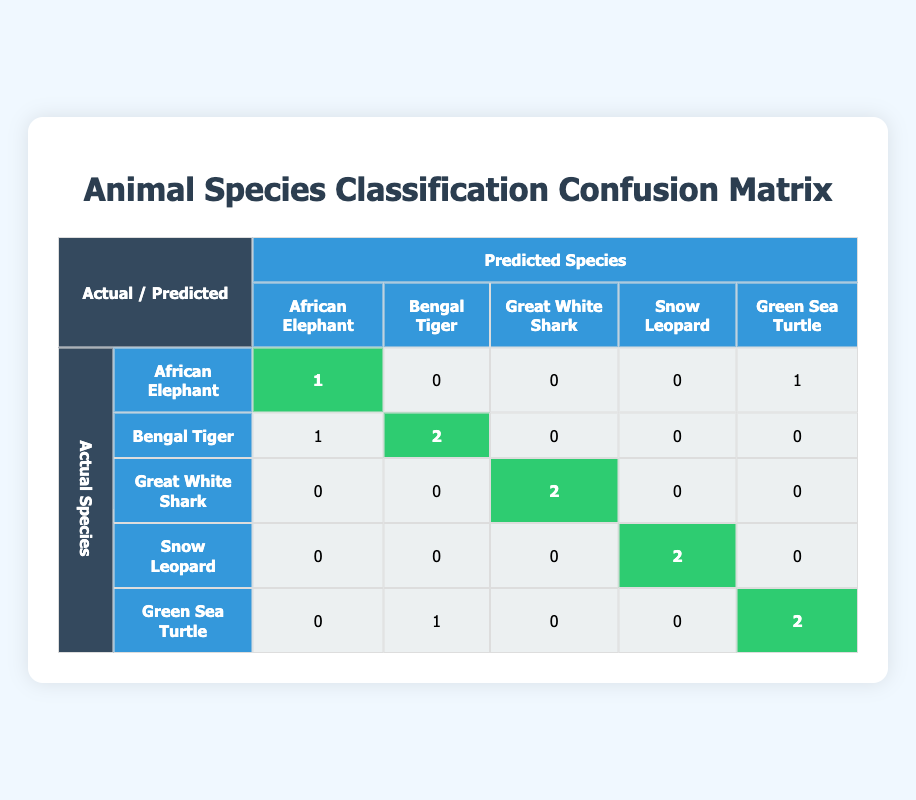What is the number of Bengal Tigers predicted correctly? In the confusion matrix, we look at the row for Bengal Tiger. The diagonal cell for Bengal Tiger shows a value of 2, which represents the number of times the model correctly predicted it as a Bengal Tiger.
Answer: 2 How many species were misclassified as African Elephants? To find the misclassifications, we look at the column for African Elephant. We see that there is a value of 1 for Bengal Tiger, indicating that one Bengal Tiger was incorrectly predicted as an African Elephant.
Answer: 1 What is the total number of misclassifications across all species? We need to sum all the off-diagonal values in the confusion matrix to get the total misclassifications. For all species, the values are 0 (African Elephant) + 1 (Bengal Tiger) + 0 (Great White Shark) + 0 (Snow Leopard) + 0 (Green Sea Turtle) = 1 for African Elephant, and so on. Summing them up gives us 1 + 1 + 0 + 0 + 1 = 3.
Answer: 3 True or False: Great White Shark was predicted correctly two times. Looking at the row for Great White Shark, we see that the diagonal cell has a value of 2, which indicates that it was predicted correctly two times. Therefore, the statement holds true.
Answer: True What is the average number of correct predictions for each species? To find the average correct predictions, we sum the diagonal values (true positives) which are 1 (African Elephant) + 2 (Bengal Tiger) + 2 (Great White Shark) + 2 (Snow Leopard) + 2 (Green Sea Turtle) = 9 and then divide by the number of species (5) to find an average of 9/5 = 1.8.
Answer: 1.8 How many predictions were made for Green Sea Turtle, both correct and incorrect? We check the row for Green Sea Turtle to find the total predictions. The row shows 0 correct predictions (diagonal cell) and 1 misclassified as Bengal Tiger, and 2 correct predictions (diagonal cell). Adding these gives us a total of 3 predictions for Green Sea Turtle (1 + 2).
Answer: 3 Which species had the highest number of misclassifications? We analyze the confusion matrix for values off the diagonal for each species. The maximum misclassification count can be observed in the row for Green Sea Turtle, where it has 1 (Bengal Tiger) as misclassification along with 0 for the others, showing its highest misinformation totals.
Answer: Green Sea Turtle What percentage of the predictions for Snow Leopard were incorrect? The diagonal value for Snow Leopard is 2 (correct predictions). To find incorrect predictions, we need to look at the values that are not on the diagonal, which is 0 (Bengal Tiger), 0 (Great White Shark), and 0 (Green Sea Turtle), thus summing up to 0 incorrect predictions. The percentage is (0 incorrect / 2 total) * 100 = 0%.
Answer: 0% 